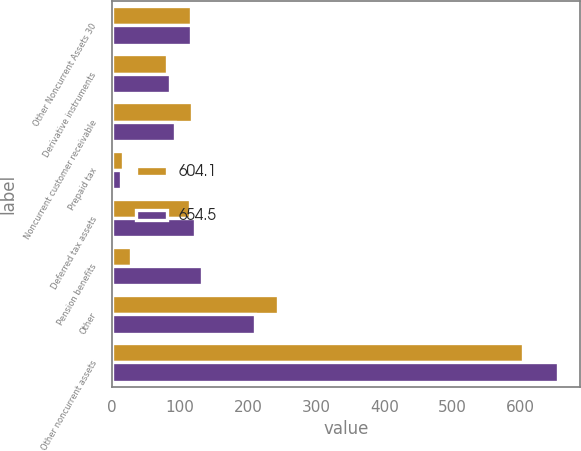<chart> <loc_0><loc_0><loc_500><loc_500><stacked_bar_chart><ecel><fcel>Other Noncurrent Assets 30<fcel>Derivative instruments<fcel>Noncurrent customer receivable<fcel>Prepaid tax<fcel>Deferred tax assets<fcel>Pension benefits<fcel>Other<fcel>Other noncurrent assets<nl><fcel>604.1<fcel>116.6<fcel>81.7<fcel>118<fcel>17<fcel>115.2<fcel>28.7<fcel>243.5<fcel>604.1<nl><fcel>654.5<fcel>116.6<fcel>85<fcel>92.4<fcel>13.2<fcel>121.4<fcel>131.7<fcel>210.8<fcel>654.5<nl></chart> 